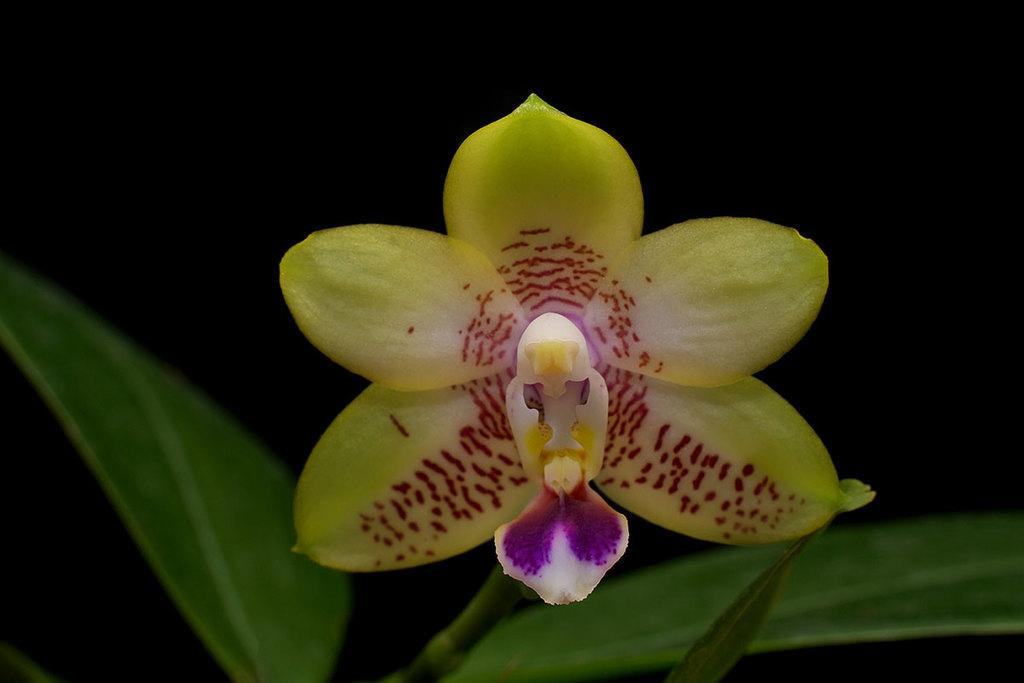What type of plant is visible in the image? There is a flower on a plant in the image. What type of rice is being served on the desk in the image? There is no rice or desk present in the image; it only features a flower on a plant. What type of tail is visible on the animal in the image? There is no animal or tail present in the image; it only features a flower on a plant. 